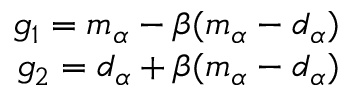Convert formula to latex. <formula><loc_0><loc_0><loc_500><loc_500>\begin{array} { r } { g _ { 1 } = m _ { \alpha } - \beta ( m _ { \alpha } - d _ { \alpha } ) } \\ { g _ { 2 } = d _ { \alpha } + \beta ( m _ { \alpha } - d _ { \alpha } ) } \end{array}</formula> 